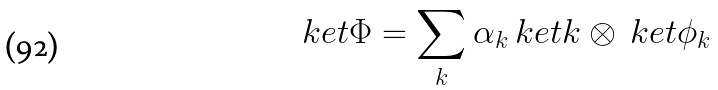Convert formula to latex. <formula><loc_0><loc_0><loc_500><loc_500>\ k e t { \Phi } = \sum _ { k } \alpha _ { k } \ k e t { k } \otimes \ k e t { \phi _ { k } }</formula> 